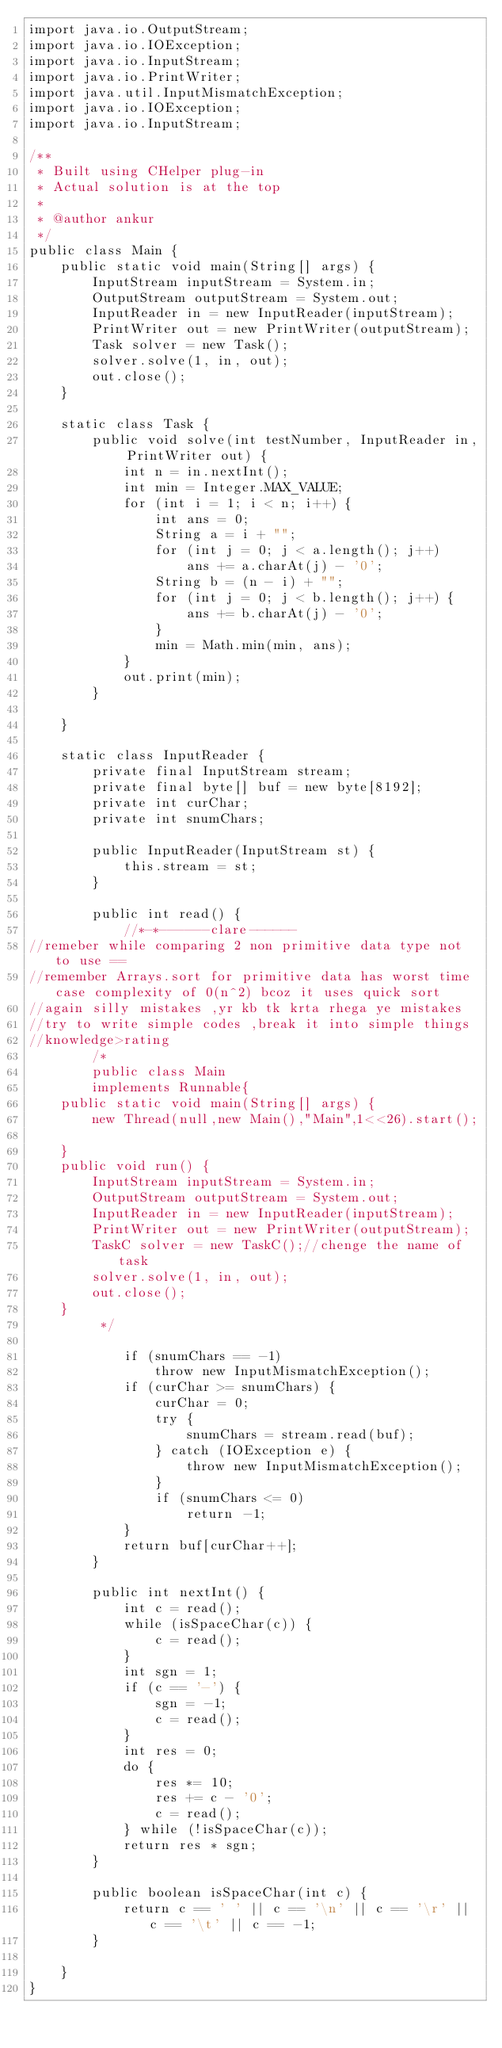Convert code to text. <code><loc_0><loc_0><loc_500><loc_500><_Java_>import java.io.OutputStream;
import java.io.IOException;
import java.io.InputStream;
import java.io.PrintWriter;
import java.util.InputMismatchException;
import java.io.IOException;
import java.io.InputStream;

/**
 * Built using CHelper plug-in
 * Actual solution is at the top
 *
 * @author ankur
 */
public class Main {
    public static void main(String[] args) {
        InputStream inputStream = System.in;
        OutputStream outputStream = System.out;
        InputReader in = new InputReader(inputStream);
        PrintWriter out = new PrintWriter(outputStream);
        Task solver = new Task();
        solver.solve(1, in, out);
        out.close();
    }

    static class Task {
        public void solve(int testNumber, InputReader in, PrintWriter out) {
            int n = in.nextInt();
            int min = Integer.MAX_VALUE;
            for (int i = 1; i < n; i++) {
                int ans = 0;
                String a = i + "";
                for (int j = 0; j < a.length(); j++)
                    ans += a.charAt(j) - '0';
                String b = (n - i) + "";
                for (int j = 0; j < b.length(); j++) {
                    ans += b.charAt(j) - '0';
                }
                min = Math.min(min, ans);
            }
            out.print(min);
        }

    }

    static class InputReader {
        private final InputStream stream;
        private final byte[] buf = new byte[8192];
        private int curChar;
        private int snumChars;

        public InputReader(InputStream st) {
            this.stream = st;
        }

        public int read() {
            //*-*------clare------
//remeber while comparing 2 non primitive data type not to use ==
//remember Arrays.sort for primitive data has worst time case complexity of 0(n^2) bcoz it uses quick sort
//again silly mistakes ,yr kb tk krta rhega ye mistakes
//try to write simple codes ,break it into simple things
//knowledge>rating
        /*
        public class Main
        implements Runnable{
    public static void main(String[] args) {
        new Thread(null,new Main(),"Main",1<<26).start();

    }
    public void run() {
        InputStream inputStream = System.in;
        OutputStream outputStream = System.out;
        InputReader in = new InputReader(inputStream);
        PrintWriter out = new PrintWriter(outputStream);
        TaskC solver = new TaskC();//chenge the name of task
        solver.solve(1, in, out);
        out.close();
    }
         */

            if (snumChars == -1)
                throw new InputMismatchException();
            if (curChar >= snumChars) {
                curChar = 0;
                try {
                    snumChars = stream.read(buf);
                } catch (IOException e) {
                    throw new InputMismatchException();
                }
                if (snumChars <= 0)
                    return -1;
            }
            return buf[curChar++];
        }

        public int nextInt() {
            int c = read();
            while (isSpaceChar(c)) {
                c = read();
            }
            int sgn = 1;
            if (c == '-') {
                sgn = -1;
                c = read();
            }
            int res = 0;
            do {
                res *= 10;
                res += c - '0';
                c = read();
            } while (!isSpaceChar(c));
            return res * sgn;
        }

        public boolean isSpaceChar(int c) {
            return c == ' ' || c == '\n' || c == '\r' || c == '\t' || c == -1;
        }

    }
}

</code> 